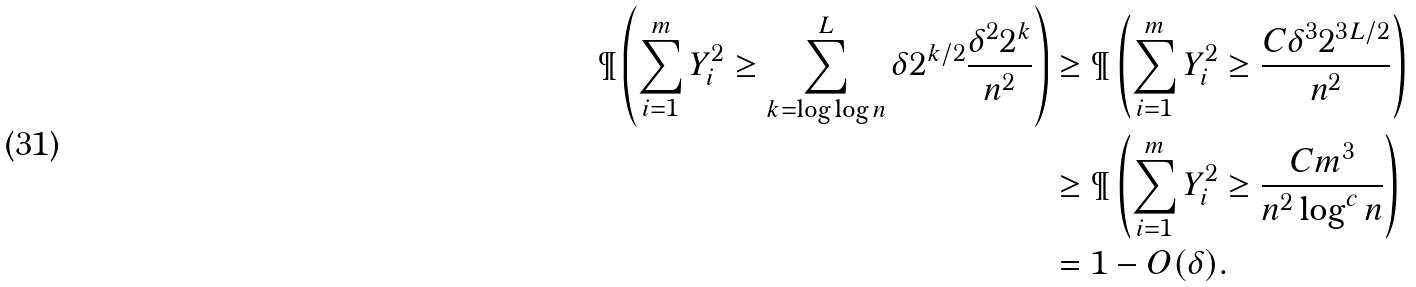Convert formula to latex. <formula><loc_0><loc_0><loc_500><loc_500>\P \left ( \sum _ { i = 1 } ^ { m } Y _ { i } ^ { 2 } \geq \sum _ { k = \log \log n } ^ { L } \delta 2 ^ { k / 2 } \frac { \delta ^ { 2 } 2 ^ { k } } { n ^ { 2 } } \right ) & \geq \P \left ( \sum _ { i = 1 } ^ { m } Y _ { i } ^ { 2 } \geq \frac { C \delta ^ { 3 } 2 ^ { 3 L / 2 } } { n ^ { 2 } } \right ) \\ & \geq \P \left ( \sum _ { i = 1 } ^ { m } Y _ { i } ^ { 2 } \geq \frac { C m ^ { 3 } } { n ^ { 2 } \log ^ { c } n } \right ) \\ & = 1 - O ( \delta ) .</formula> 